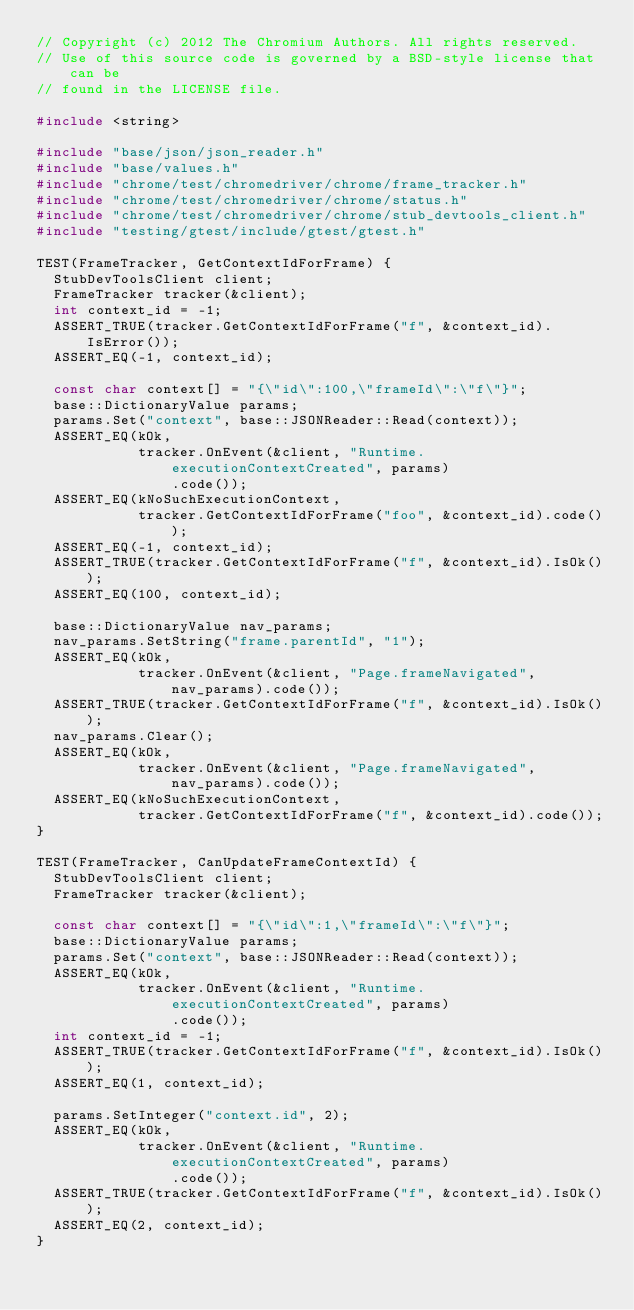<code> <loc_0><loc_0><loc_500><loc_500><_C++_>// Copyright (c) 2012 The Chromium Authors. All rights reserved.
// Use of this source code is governed by a BSD-style license that can be
// found in the LICENSE file.

#include <string>

#include "base/json/json_reader.h"
#include "base/values.h"
#include "chrome/test/chromedriver/chrome/frame_tracker.h"
#include "chrome/test/chromedriver/chrome/status.h"
#include "chrome/test/chromedriver/chrome/stub_devtools_client.h"
#include "testing/gtest/include/gtest/gtest.h"

TEST(FrameTracker, GetContextIdForFrame) {
  StubDevToolsClient client;
  FrameTracker tracker(&client);
  int context_id = -1;
  ASSERT_TRUE(tracker.GetContextIdForFrame("f", &context_id).IsError());
  ASSERT_EQ(-1, context_id);

  const char context[] = "{\"id\":100,\"frameId\":\"f\"}";
  base::DictionaryValue params;
  params.Set("context", base::JSONReader::Read(context));
  ASSERT_EQ(kOk,
            tracker.OnEvent(&client, "Runtime.executionContextCreated", params)
                .code());
  ASSERT_EQ(kNoSuchExecutionContext,
            tracker.GetContextIdForFrame("foo", &context_id).code());
  ASSERT_EQ(-1, context_id);
  ASSERT_TRUE(tracker.GetContextIdForFrame("f", &context_id).IsOk());
  ASSERT_EQ(100, context_id);

  base::DictionaryValue nav_params;
  nav_params.SetString("frame.parentId", "1");
  ASSERT_EQ(kOk,
            tracker.OnEvent(&client, "Page.frameNavigated", nav_params).code());
  ASSERT_TRUE(tracker.GetContextIdForFrame("f", &context_id).IsOk());
  nav_params.Clear();
  ASSERT_EQ(kOk,
            tracker.OnEvent(&client, "Page.frameNavigated", nav_params).code());
  ASSERT_EQ(kNoSuchExecutionContext,
            tracker.GetContextIdForFrame("f", &context_id).code());
}

TEST(FrameTracker, CanUpdateFrameContextId) {
  StubDevToolsClient client;
  FrameTracker tracker(&client);

  const char context[] = "{\"id\":1,\"frameId\":\"f\"}";
  base::DictionaryValue params;
  params.Set("context", base::JSONReader::Read(context));
  ASSERT_EQ(kOk,
            tracker.OnEvent(&client, "Runtime.executionContextCreated", params)
                .code());
  int context_id = -1;
  ASSERT_TRUE(tracker.GetContextIdForFrame("f", &context_id).IsOk());
  ASSERT_EQ(1, context_id);

  params.SetInteger("context.id", 2);
  ASSERT_EQ(kOk,
            tracker.OnEvent(&client, "Runtime.executionContextCreated", params)
                .code());
  ASSERT_TRUE(tracker.GetContextIdForFrame("f", &context_id).IsOk());
  ASSERT_EQ(2, context_id);
}
</code> 